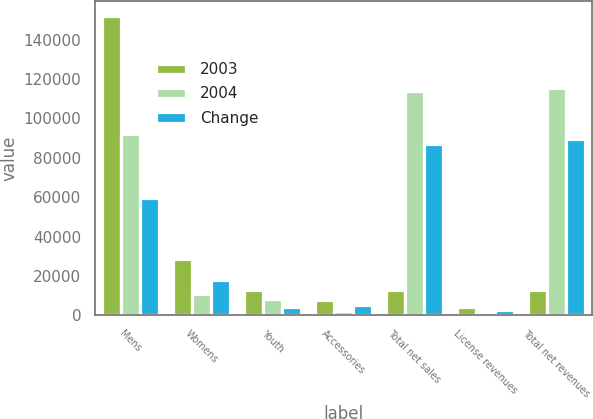Convert chart to OTSL. <chart><loc_0><loc_0><loc_500><loc_500><stacked_bar_chart><ecel><fcel>Mens<fcel>Womens<fcel>Youth<fcel>Accessories<fcel>Total net sales<fcel>License revenues<fcel>Total net revenues<nl><fcel>2003<fcel>151962<fcel>28659<fcel>12705<fcel>7548<fcel>12705<fcel>4307<fcel>12705<nl><fcel>2004<fcel>92197<fcel>10968<fcel>8518<fcel>2072<fcel>113755<fcel>1664<fcel>115419<nl><fcel>Change<fcel>59765<fcel>17691<fcel>4187<fcel>5476<fcel>87119<fcel>2643<fcel>89762<nl></chart> 